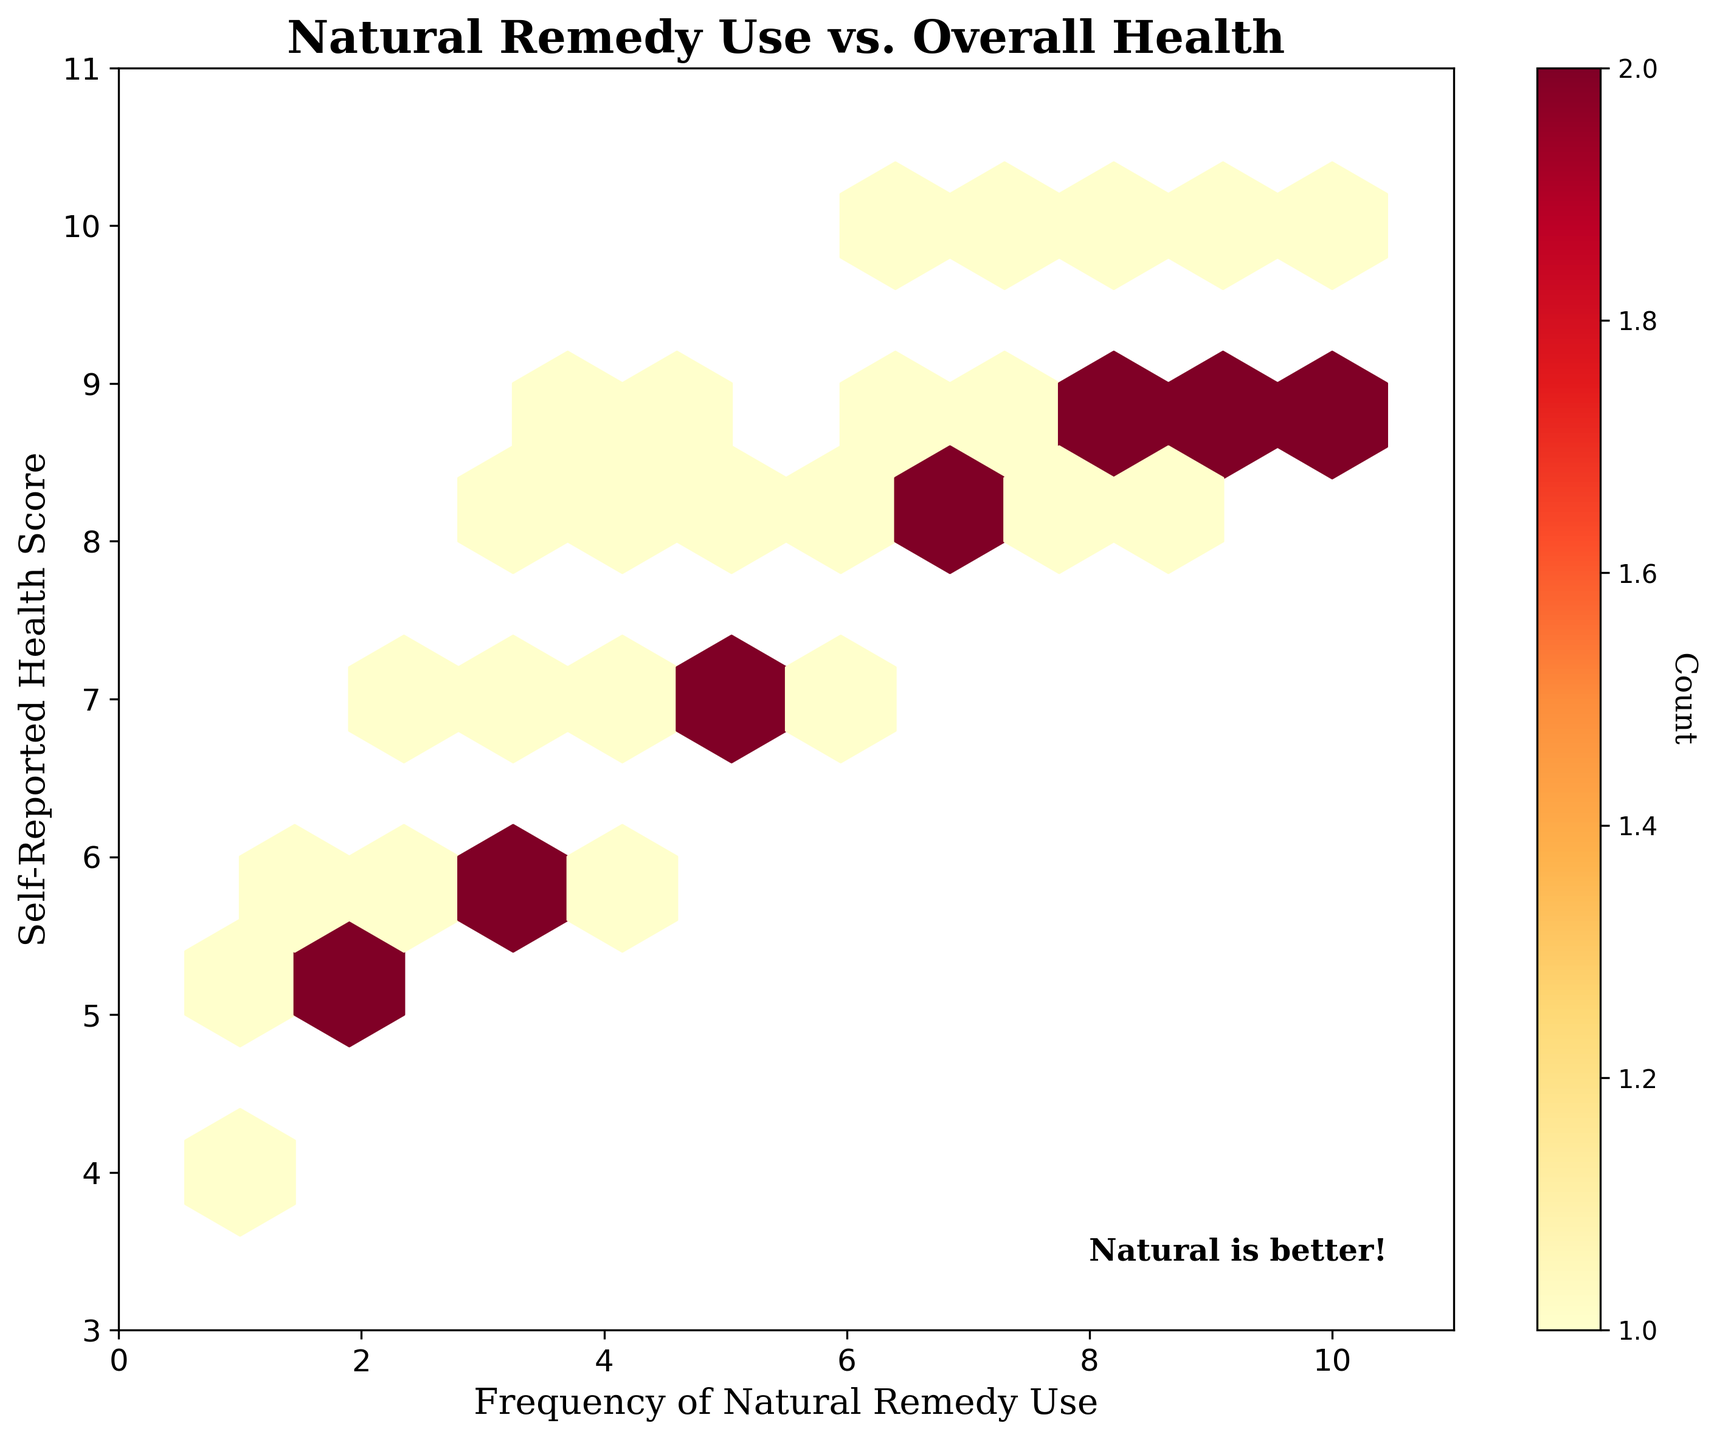What is the title of the plot? The title of the plot is found at the top center of the figure and reads "Natural Remedy Use vs. Overall Health."
Answer: Natural Remedy Use vs. Overall Health What do the x and y-axes represent? The x-axis represents the "Frequency of Natural Remedy Use," and the y-axis represents the "Self-Reported Health Score." This information is labeled on the respective axes.
Answer: Frequency of Natural Remedy Use (x-axis), Self-Reported Health Score (y-axis) What color represents the higher density of data points? The color represents the density of data points, and the progression from light yellow to dark red indicates an increasing density. Dark red represents the highest density of data points.
Answer: Dark Red What is the range of the x-axis values? The x-axis values range from 0 to 11. This information is deduced by examining the limits set on the x-axis.
Answer: 0 to 11 What is the range of the y-axis values? The y-axis values range from 3 to 11. This observation is based on the settings of the y-axis limits.
Answer: 3 to 11 Where is the highest concentration of data points on the plot? The highest concentration of data points on the plot is where the hexagons are darkest. This region appears to be around frequent remedy use of 9 and health scores of 9.
Answer: Around Frequency of Use = 9 and Health Score = 9 What does the color bar represent? The color bar represents the count of data points within each hexagon. This is indicated by the label "Count" on the color bar.
Answer: Count Is there any text annotation in the plot? Yes, there is text annotation in the plot. It reads "Natural is better!" and is located at the lower right corner within the plot area.
Answer: Natural is better! Compare the density of data points for frequency 2 and frequency 9. By examining the hexagons around frequency 2 and frequency 9, we can see that the density is higher around frequency 9 (dark red) compared to frequency 2 (lighter colors).
Answer: Higher at frequency 9 Are there more data points with a health score of 10 or 5? The density of data points with a health score of 10 is higher compared to those with a health score of 5, as indicated by darker hexagons around 10.
Answer: Health score of 10 